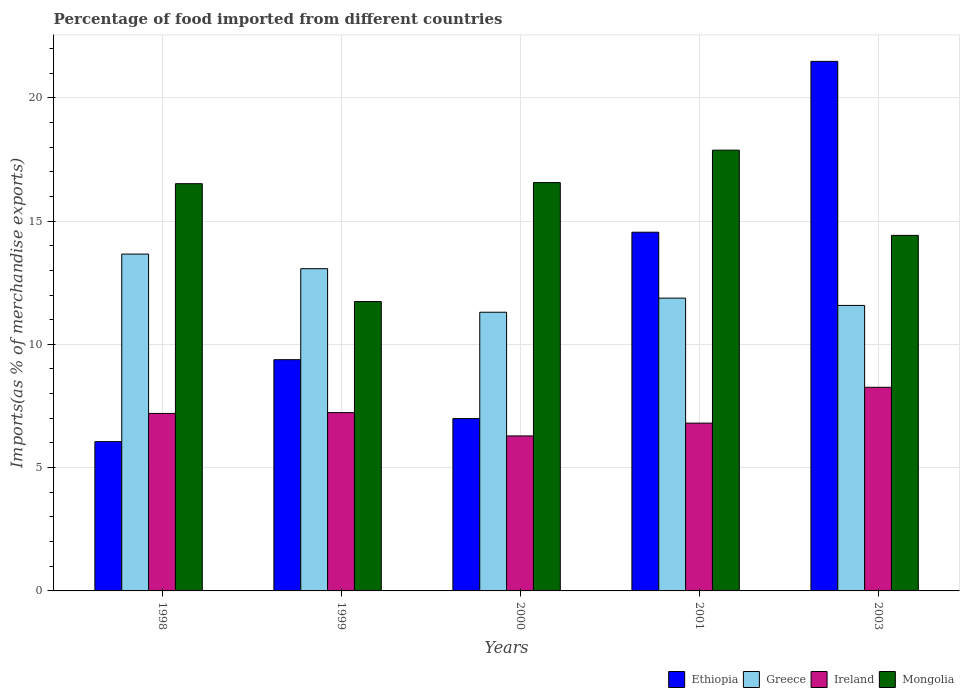Are the number of bars on each tick of the X-axis equal?
Your answer should be very brief. Yes. How many bars are there on the 4th tick from the right?
Offer a very short reply. 4. What is the label of the 2nd group of bars from the left?
Offer a terse response. 1999. In how many cases, is the number of bars for a given year not equal to the number of legend labels?
Your answer should be very brief. 0. What is the percentage of imports to different countries in Ethiopia in 2000?
Keep it short and to the point. 6.99. Across all years, what is the maximum percentage of imports to different countries in Ireland?
Offer a terse response. 8.26. Across all years, what is the minimum percentage of imports to different countries in Greece?
Your answer should be compact. 11.3. In which year was the percentage of imports to different countries in Ireland maximum?
Provide a succinct answer. 2003. In which year was the percentage of imports to different countries in Ireland minimum?
Provide a succinct answer. 2000. What is the total percentage of imports to different countries in Greece in the graph?
Provide a short and direct response. 61.48. What is the difference between the percentage of imports to different countries in Greece in 1999 and that in 2000?
Offer a terse response. 1.77. What is the difference between the percentage of imports to different countries in Greece in 1998 and the percentage of imports to different countries in Mongolia in 2001?
Your answer should be very brief. -4.21. What is the average percentage of imports to different countries in Mongolia per year?
Keep it short and to the point. 15.42. In the year 2003, what is the difference between the percentage of imports to different countries in Ireland and percentage of imports to different countries in Ethiopia?
Keep it short and to the point. -13.22. What is the ratio of the percentage of imports to different countries in Ethiopia in 2000 to that in 2003?
Offer a very short reply. 0.33. Is the difference between the percentage of imports to different countries in Ireland in 1998 and 2000 greater than the difference between the percentage of imports to different countries in Ethiopia in 1998 and 2000?
Your answer should be very brief. Yes. What is the difference between the highest and the second highest percentage of imports to different countries in Mongolia?
Your response must be concise. 1.31. What is the difference between the highest and the lowest percentage of imports to different countries in Mongolia?
Provide a short and direct response. 6.14. In how many years, is the percentage of imports to different countries in Greece greater than the average percentage of imports to different countries in Greece taken over all years?
Offer a terse response. 2. What does the 4th bar from the left in 2003 represents?
Keep it short and to the point. Mongolia. What does the 4th bar from the right in 2003 represents?
Give a very brief answer. Ethiopia. How many bars are there?
Provide a short and direct response. 20. How many years are there in the graph?
Provide a short and direct response. 5. Are the values on the major ticks of Y-axis written in scientific E-notation?
Ensure brevity in your answer.  No. Does the graph contain any zero values?
Give a very brief answer. No. Does the graph contain grids?
Your answer should be very brief. Yes. Where does the legend appear in the graph?
Your response must be concise. Bottom right. How are the legend labels stacked?
Your response must be concise. Horizontal. What is the title of the graph?
Keep it short and to the point. Percentage of food imported from different countries. Does "Portugal" appear as one of the legend labels in the graph?
Keep it short and to the point. No. What is the label or title of the X-axis?
Your answer should be compact. Years. What is the label or title of the Y-axis?
Make the answer very short. Imports(as % of merchandise exports). What is the Imports(as % of merchandise exports) in Ethiopia in 1998?
Offer a very short reply. 6.05. What is the Imports(as % of merchandise exports) in Greece in 1998?
Provide a short and direct response. 13.66. What is the Imports(as % of merchandise exports) of Ireland in 1998?
Provide a short and direct response. 7.2. What is the Imports(as % of merchandise exports) in Mongolia in 1998?
Offer a very short reply. 16.51. What is the Imports(as % of merchandise exports) in Ethiopia in 1999?
Provide a succinct answer. 9.38. What is the Imports(as % of merchandise exports) in Greece in 1999?
Give a very brief answer. 13.07. What is the Imports(as % of merchandise exports) of Ireland in 1999?
Give a very brief answer. 7.23. What is the Imports(as % of merchandise exports) in Mongolia in 1999?
Ensure brevity in your answer.  11.73. What is the Imports(as % of merchandise exports) of Ethiopia in 2000?
Give a very brief answer. 6.99. What is the Imports(as % of merchandise exports) of Greece in 2000?
Offer a very short reply. 11.3. What is the Imports(as % of merchandise exports) of Ireland in 2000?
Offer a terse response. 6.29. What is the Imports(as % of merchandise exports) of Mongolia in 2000?
Make the answer very short. 16.56. What is the Imports(as % of merchandise exports) in Ethiopia in 2001?
Ensure brevity in your answer.  14.55. What is the Imports(as % of merchandise exports) of Greece in 2001?
Offer a terse response. 11.87. What is the Imports(as % of merchandise exports) of Ireland in 2001?
Give a very brief answer. 6.8. What is the Imports(as % of merchandise exports) in Mongolia in 2001?
Your answer should be very brief. 17.87. What is the Imports(as % of merchandise exports) in Ethiopia in 2003?
Give a very brief answer. 21.47. What is the Imports(as % of merchandise exports) in Greece in 2003?
Your answer should be compact. 11.58. What is the Imports(as % of merchandise exports) of Ireland in 2003?
Give a very brief answer. 8.26. What is the Imports(as % of merchandise exports) of Mongolia in 2003?
Your answer should be compact. 14.42. Across all years, what is the maximum Imports(as % of merchandise exports) in Ethiopia?
Your answer should be compact. 21.47. Across all years, what is the maximum Imports(as % of merchandise exports) of Greece?
Offer a very short reply. 13.66. Across all years, what is the maximum Imports(as % of merchandise exports) of Ireland?
Make the answer very short. 8.26. Across all years, what is the maximum Imports(as % of merchandise exports) of Mongolia?
Offer a terse response. 17.87. Across all years, what is the minimum Imports(as % of merchandise exports) of Ethiopia?
Your response must be concise. 6.05. Across all years, what is the minimum Imports(as % of merchandise exports) in Greece?
Your answer should be compact. 11.3. Across all years, what is the minimum Imports(as % of merchandise exports) in Ireland?
Provide a short and direct response. 6.29. Across all years, what is the minimum Imports(as % of merchandise exports) in Mongolia?
Make the answer very short. 11.73. What is the total Imports(as % of merchandise exports) of Ethiopia in the graph?
Provide a short and direct response. 58.44. What is the total Imports(as % of merchandise exports) of Greece in the graph?
Your answer should be very brief. 61.48. What is the total Imports(as % of merchandise exports) of Ireland in the graph?
Offer a terse response. 35.78. What is the total Imports(as % of merchandise exports) in Mongolia in the graph?
Give a very brief answer. 77.1. What is the difference between the Imports(as % of merchandise exports) of Ethiopia in 1998 and that in 1999?
Make the answer very short. -3.32. What is the difference between the Imports(as % of merchandise exports) of Greece in 1998 and that in 1999?
Offer a terse response. 0.59. What is the difference between the Imports(as % of merchandise exports) of Ireland in 1998 and that in 1999?
Keep it short and to the point. -0.03. What is the difference between the Imports(as % of merchandise exports) in Mongolia in 1998 and that in 1999?
Your response must be concise. 4.78. What is the difference between the Imports(as % of merchandise exports) of Ethiopia in 1998 and that in 2000?
Keep it short and to the point. -0.94. What is the difference between the Imports(as % of merchandise exports) of Greece in 1998 and that in 2000?
Your answer should be compact. 2.36. What is the difference between the Imports(as % of merchandise exports) in Ireland in 1998 and that in 2000?
Ensure brevity in your answer.  0.91. What is the difference between the Imports(as % of merchandise exports) of Mongolia in 1998 and that in 2000?
Ensure brevity in your answer.  -0.05. What is the difference between the Imports(as % of merchandise exports) in Ethiopia in 1998 and that in 2001?
Give a very brief answer. -8.49. What is the difference between the Imports(as % of merchandise exports) in Greece in 1998 and that in 2001?
Make the answer very short. 1.79. What is the difference between the Imports(as % of merchandise exports) in Ireland in 1998 and that in 2001?
Provide a succinct answer. 0.39. What is the difference between the Imports(as % of merchandise exports) of Mongolia in 1998 and that in 2001?
Offer a very short reply. -1.36. What is the difference between the Imports(as % of merchandise exports) in Ethiopia in 1998 and that in 2003?
Offer a very short reply. -15.42. What is the difference between the Imports(as % of merchandise exports) in Greece in 1998 and that in 2003?
Your answer should be compact. 2.08. What is the difference between the Imports(as % of merchandise exports) of Ireland in 1998 and that in 2003?
Provide a succinct answer. -1.06. What is the difference between the Imports(as % of merchandise exports) of Mongolia in 1998 and that in 2003?
Your response must be concise. 2.1. What is the difference between the Imports(as % of merchandise exports) of Ethiopia in 1999 and that in 2000?
Provide a succinct answer. 2.39. What is the difference between the Imports(as % of merchandise exports) in Greece in 1999 and that in 2000?
Provide a succinct answer. 1.77. What is the difference between the Imports(as % of merchandise exports) in Ireland in 1999 and that in 2000?
Your answer should be very brief. 0.95. What is the difference between the Imports(as % of merchandise exports) in Mongolia in 1999 and that in 2000?
Keep it short and to the point. -4.82. What is the difference between the Imports(as % of merchandise exports) of Ethiopia in 1999 and that in 2001?
Keep it short and to the point. -5.17. What is the difference between the Imports(as % of merchandise exports) in Greece in 1999 and that in 2001?
Make the answer very short. 1.19. What is the difference between the Imports(as % of merchandise exports) of Ireland in 1999 and that in 2001?
Your response must be concise. 0.43. What is the difference between the Imports(as % of merchandise exports) of Mongolia in 1999 and that in 2001?
Provide a succinct answer. -6.14. What is the difference between the Imports(as % of merchandise exports) of Ethiopia in 1999 and that in 2003?
Provide a succinct answer. -12.1. What is the difference between the Imports(as % of merchandise exports) of Greece in 1999 and that in 2003?
Your response must be concise. 1.49. What is the difference between the Imports(as % of merchandise exports) in Ireland in 1999 and that in 2003?
Offer a terse response. -1.03. What is the difference between the Imports(as % of merchandise exports) of Mongolia in 1999 and that in 2003?
Make the answer very short. -2.68. What is the difference between the Imports(as % of merchandise exports) of Ethiopia in 2000 and that in 2001?
Provide a succinct answer. -7.56. What is the difference between the Imports(as % of merchandise exports) in Greece in 2000 and that in 2001?
Ensure brevity in your answer.  -0.57. What is the difference between the Imports(as % of merchandise exports) of Ireland in 2000 and that in 2001?
Provide a short and direct response. -0.52. What is the difference between the Imports(as % of merchandise exports) in Mongolia in 2000 and that in 2001?
Your answer should be compact. -1.31. What is the difference between the Imports(as % of merchandise exports) in Ethiopia in 2000 and that in 2003?
Provide a succinct answer. -14.49. What is the difference between the Imports(as % of merchandise exports) of Greece in 2000 and that in 2003?
Your answer should be compact. -0.28. What is the difference between the Imports(as % of merchandise exports) in Ireland in 2000 and that in 2003?
Provide a succinct answer. -1.97. What is the difference between the Imports(as % of merchandise exports) in Mongolia in 2000 and that in 2003?
Provide a succinct answer. 2.14. What is the difference between the Imports(as % of merchandise exports) in Ethiopia in 2001 and that in 2003?
Your answer should be very brief. -6.93. What is the difference between the Imports(as % of merchandise exports) of Greece in 2001 and that in 2003?
Your answer should be compact. 0.3. What is the difference between the Imports(as % of merchandise exports) of Ireland in 2001 and that in 2003?
Offer a terse response. -1.45. What is the difference between the Imports(as % of merchandise exports) in Mongolia in 2001 and that in 2003?
Provide a short and direct response. 3.46. What is the difference between the Imports(as % of merchandise exports) in Ethiopia in 1998 and the Imports(as % of merchandise exports) in Greece in 1999?
Provide a succinct answer. -7.01. What is the difference between the Imports(as % of merchandise exports) in Ethiopia in 1998 and the Imports(as % of merchandise exports) in Ireland in 1999?
Your answer should be very brief. -1.18. What is the difference between the Imports(as % of merchandise exports) in Ethiopia in 1998 and the Imports(as % of merchandise exports) in Mongolia in 1999?
Your answer should be very brief. -5.68. What is the difference between the Imports(as % of merchandise exports) in Greece in 1998 and the Imports(as % of merchandise exports) in Ireland in 1999?
Give a very brief answer. 6.43. What is the difference between the Imports(as % of merchandise exports) of Greece in 1998 and the Imports(as % of merchandise exports) of Mongolia in 1999?
Offer a terse response. 1.93. What is the difference between the Imports(as % of merchandise exports) of Ireland in 1998 and the Imports(as % of merchandise exports) of Mongolia in 1999?
Offer a very short reply. -4.54. What is the difference between the Imports(as % of merchandise exports) in Ethiopia in 1998 and the Imports(as % of merchandise exports) in Greece in 2000?
Provide a succinct answer. -5.25. What is the difference between the Imports(as % of merchandise exports) of Ethiopia in 1998 and the Imports(as % of merchandise exports) of Ireland in 2000?
Your answer should be compact. -0.23. What is the difference between the Imports(as % of merchandise exports) in Ethiopia in 1998 and the Imports(as % of merchandise exports) in Mongolia in 2000?
Give a very brief answer. -10.5. What is the difference between the Imports(as % of merchandise exports) of Greece in 1998 and the Imports(as % of merchandise exports) of Ireland in 2000?
Your answer should be very brief. 7.37. What is the difference between the Imports(as % of merchandise exports) in Greece in 1998 and the Imports(as % of merchandise exports) in Mongolia in 2000?
Give a very brief answer. -2.9. What is the difference between the Imports(as % of merchandise exports) in Ireland in 1998 and the Imports(as % of merchandise exports) in Mongolia in 2000?
Make the answer very short. -9.36. What is the difference between the Imports(as % of merchandise exports) of Ethiopia in 1998 and the Imports(as % of merchandise exports) of Greece in 2001?
Your response must be concise. -5.82. What is the difference between the Imports(as % of merchandise exports) in Ethiopia in 1998 and the Imports(as % of merchandise exports) in Ireland in 2001?
Your answer should be compact. -0.75. What is the difference between the Imports(as % of merchandise exports) of Ethiopia in 1998 and the Imports(as % of merchandise exports) of Mongolia in 2001?
Your answer should be very brief. -11.82. What is the difference between the Imports(as % of merchandise exports) in Greece in 1998 and the Imports(as % of merchandise exports) in Ireland in 2001?
Provide a succinct answer. 6.85. What is the difference between the Imports(as % of merchandise exports) of Greece in 1998 and the Imports(as % of merchandise exports) of Mongolia in 2001?
Give a very brief answer. -4.21. What is the difference between the Imports(as % of merchandise exports) in Ireland in 1998 and the Imports(as % of merchandise exports) in Mongolia in 2001?
Provide a succinct answer. -10.68. What is the difference between the Imports(as % of merchandise exports) of Ethiopia in 1998 and the Imports(as % of merchandise exports) of Greece in 2003?
Keep it short and to the point. -5.52. What is the difference between the Imports(as % of merchandise exports) of Ethiopia in 1998 and the Imports(as % of merchandise exports) of Ireland in 2003?
Your answer should be very brief. -2.2. What is the difference between the Imports(as % of merchandise exports) of Ethiopia in 1998 and the Imports(as % of merchandise exports) of Mongolia in 2003?
Give a very brief answer. -8.36. What is the difference between the Imports(as % of merchandise exports) of Greece in 1998 and the Imports(as % of merchandise exports) of Ireland in 2003?
Offer a terse response. 5.4. What is the difference between the Imports(as % of merchandise exports) of Greece in 1998 and the Imports(as % of merchandise exports) of Mongolia in 2003?
Ensure brevity in your answer.  -0.76. What is the difference between the Imports(as % of merchandise exports) of Ireland in 1998 and the Imports(as % of merchandise exports) of Mongolia in 2003?
Your response must be concise. -7.22. What is the difference between the Imports(as % of merchandise exports) in Ethiopia in 1999 and the Imports(as % of merchandise exports) in Greece in 2000?
Offer a terse response. -1.93. What is the difference between the Imports(as % of merchandise exports) in Ethiopia in 1999 and the Imports(as % of merchandise exports) in Ireland in 2000?
Your answer should be compact. 3.09. What is the difference between the Imports(as % of merchandise exports) of Ethiopia in 1999 and the Imports(as % of merchandise exports) of Mongolia in 2000?
Make the answer very short. -7.18. What is the difference between the Imports(as % of merchandise exports) in Greece in 1999 and the Imports(as % of merchandise exports) in Ireland in 2000?
Your response must be concise. 6.78. What is the difference between the Imports(as % of merchandise exports) of Greece in 1999 and the Imports(as % of merchandise exports) of Mongolia in 2000?
Make the answer very short. -3.49. What is the difference between the Imports(as % of merchandise exports) of Ireland in 1999 and the Imports(as % of merchandise exports) of Mongolia in 2000?
Make the answer very short. -9.33. What is the difference between the Imports(as % of merchandise exports) of Ethiopia in 1999 and the Imports(as % of merchandise exports) of Greece in 2001?
Ensure brevity in your answer.  -2.5. What is the difference between the Imports(as % of merchandise exports) in Ethiopia in 1999 and the Imports(as % of merchandise exports) in Ireland in 2001?
Provide a succinct answer. 2.57. What is the difference between the Imports(as % of merchandise exports) in Ethiopia in 1999 and the Imports(as % of merchandise exports) in Mongolia in 2001?
Your response must be concise. -8.5. What is the difference between the Imports(as % of merchandise exports) of Greece in 1999 and the Imports(as % of merchandise exports) of Ireland in 2001?
Keep it short and to the point. 6.26. What is the difference between the Imports(as % of merchandise exports) in Greece in 1999 and the Imports(as % of merchandise exports) in Mongolia in 2001?
Keep it short and to the point. -4.81. What is the difference between the Imports(as % of merchandise exports) of Ireland in 1999 and the Imports(as % of merchandise exports) of Mongolia in 2001?
Your answer should be compact. -10.64. What is the difference between the Imports(as % of merchandise exports) of Ethiopia in 1999 and the Imports(as % of merchandise exports) of Greece in 2003?
Keep it short and to the point. -2.2. What is the difference between the Imports(as % of merchandise exports) of Ethiopia in 1999 and the Imports(as % of merchandise exports) of Ireland in 2003?
Your response must be concise. 1.12. What is the difference between the Imports(as % of merchandise exports) in Ethiopia in 1999 and the Imports(as % of merchandise exports) in Mongolia in 2003?
Your answer should be very brief. -5.04. What is the difference between the Imports(as % of merchandise exports) of Greece in 1999 and the Imports(as % of merchandise exports) of Ireland in 2003?
Make the answer very short. 4.81. What is the difference between the Imports(as % of merchandise exports) in Greece in 1999 and the Imports(as % of merchandise exports) in Mongolia in 2003?
Your answer should be compact. -1.35. What is the difference between the Imports(as % of merchandise exports) of Ireland in 1999 and the Imports(as % of merchandise exports) of Mongolia in 2003?
Make the answer very short. -7.19. What is the difference between the Imports(as % of merchandise exports) of Ethiopia in 2000 and the Imports(as % of merchandise exports) of Greece in 2001?
Provide a short and direct response. -4.88. What is the difference between the Imports(as % of merchandise exports) in Ethiopia in 2000 and the Imports(as % of merchandise exports) in Ireland in 2001?
Your answer should be compact. 0.18. What is the difference between the Imports(as % of merchandise exports) of Ethiopia in 2000 and the Imports(as % of merchandise exports) of Mongolia in 2001?
Make the answer very short. -10.88. What is the difference between the Imports(as % of merchandise exports) in Greece in 2000 and the Imports(as % of merchandise exports) in Ireland in 2001?
Your answer should be compact. 4.5. What is the difference between the Imports(as % of merchandise exports) in Greece in 2000 and the Imports(as % of merchandise exports) in Mongolia in 2001?
Make the answer very short. -6.57. What is the difference between the Imports(as % of merchandise exports) in Ireland in 2000 and the Imports(as % of merchandise exports) in Mongolia in 2001?
Provide a succinct answer. -11.59. What is the difference between the Imports(as % of merchandise exports) in Ethiopia in 2000 and the Imports(as % of merchandise exports) in Greece in 2003?
Make the answer very short. -4.59. What is the difference between the Imports(as % of merchandise exports) in Ethiopia in 2000 and the Imports(as % of merchandise exports) in Ireland in 2003?
Ensure brevity in your answer.  -1.27. What is the difference between the Imports(as % of merchandise exports) of Ethiopia in 2000 and the Imports(as % of merchandise exports) of Mongolia in 2003?
Make the answer very short. -7.43. What is the difference between the Imports(as % of merchandise exports) in Greece in 2000 and the Imports(as % of merchandise exports) in Ireland in 2003?
Offer a terse response. 3.04. What is the difference between the Imports(as % of merchandise exports) of Greece in 2000 and the Imports(as % of merchandise exports) of Mongolia in 2003?
Your response must be concise. -3.12. What is the difference between the Imports(as % of merchandise exports) of Ireland in 2000 and the Imports(as % of merchandise exports) of Mongolia in 2003?
Your answer should be very brief. -8.13. What is the difference between the Imports(as % of merchandise exports) of Ethiopia in 2001 and the Imports(as % of merchandise exports) of Greece in 2003?
Give a very brief answer. 2.97. What is the difference between the Imports(as % of merchandise exports) of Ethiopia in 2001 and the Imports(as % of merchandise exports) of Ireland in 2003?
Give a very brief answer. 6.29. What is the difference between the Imports(as % of merchandise exports) of Ethiopia in 2001 and the Imports(as % of merchandise exports) of Mongolia in 2003?
Your answer should be compact. 0.13. What is the difference between the Imports(as % of merchandise exports) of Greece in 2001 and the Imports(as % of merchandise exports) of Ireland in 2003?
Make the answer very short. 3.61. What is the difference between the Imports(as % of merchandise exports) of Greece in 2001 and the Imports(as % of merchandise exports) of Mongolia in 2003?
Your answer should be compact. -2.54. What is the difference between the Imports(as % of merchandise exports) in Ireland in 2001 and the Imports(as % of merchandise exports) in Mongolia in 2003?
Ensure brevity in your answer.  -7.61. What is the average Imports(as % of merchandise exports) in Ethiopia per year?
Offer a very short reply. 11.69. What is the average Imports(as % of merchandise exports) in Greece per year?
Offer a very short reply. 12.3. What is the average Imports(as % of merchandise exports) of Ireland per year?
Make the answer very short. 7.16. What is the average Imports(as % of merchandise exports) of Mongolia per year?
Ensure brevity in your answer.  15.42. In the year 1998, what is the difference between the Imports(as % of merchandise exports) of Ethiopia and Imports(as % of merchandise exports) of Greece?
Provide a short and direct response. -7.61. In the year 1998, what is the difference between the Imports(as % of merchandise exports) in Ethiopia and Imports(as % of merchandise exports) in Ireland?
Ensure brevity in your answer.  -1.14. In the year 1998, what is the difference between the Imports(as % of merchandise exports) in Ethiopia and Imports(as % of merchandise exports) in Mongolia?
Your response must be concise. -10.46. In the year 1998, what is the difference between the Imports(as % of merchandise exports) of Greece and Imports(as % of merchandise exports) of Ireland?
Ensure brevity in your answer.  6.46. In the year 1998, what is the difference between the Imports(as % of merchandise exports) in Greece and Imports(as % of merchandise exports) in Mongolia?
Your answer should be very brief. -2.85. In the year 1998, what is the difference between the Imports(as % of merchandise exports) in Ireland and Imports(as % of merchandise exports) in Mongolia?
Give a very brief answer. -9.32. In the year 1999, what is the difference between the Imports(as % of merchandise exports) in Ethiopia and Imports(as % of merchandise exports) in Greece?
Provide a short and direct response. -3.69. In the year 1999, what is the difference between the Imports(as % of merchandise exports) in Ethiopia and Imports(as % of merchandise exports) in Ireland?
Make the answer very short. 2.15. In the year 1999, what is the difference between the Imports(as % of merchandise exports) in Ethiopia and Imports(as % of merchandise exports) in Mongolia?
Your answer should be compact. -2.36. In the year 1999, what is the difference between the Imports(as % of merchandise exports) in Greece and Imports(as % of merchandise exports) in Ireland?
Offer a very short reply. 5.84. In the year 1999, what is the difference between the Imports(as % of merchandise exports) in Greece and Imports(as % of merchandise exports) in Mongolia?
Make the answer very short. 1.33. In the year 1999, what is the difference between the Imports(as % of merchandise exports) of Ireland and Imports(as % of merchandise exports) of Mongolia?
Your answer should be compact. -4.5. In the year 2000, what is the difference between the Imports(as % of merchandise exports) of Ethiopia and Imports(as % of merchandise exports) of Greece?
Keep it short and to the point. -4.31. In the year 2000, what is the difference between the Imports(as % of merchandise exports) in Ethiopia and Imports(as % of merchandise exports) in Ireland?
Provide a succinct answer. 0.7. In the year 2000, what is the difference between the Imports(as % of merchandise exports) in Ethiopia and Imports(as % of merchandise exports) in Mongolia?
Make the answer very short. -9.57. In the year 2000, what is the difference between the Imports(as % of merchandise exports) in Greece and Imports(as % of merchandise exports) in Ireland?
Provide a short and direct response. 5.02. In the year 2000, what is the difference between the Imports(as % of merchandise exports) of Greece and Imports(as % of merchandise exports) of Mongolia?
Provide a succinct answer. -5.26. In the year 2000, what is the difference between the Imports(as % of merchandise exports) of Ireland and Imports(as % of merchandise exports) of Mongolia?
Provide a succinct answer. -10.27. In the year 2001, what is the difference between the Imports(as % of merchandise exports) in Ethiopia and Imports(as % of merchandise exports) in Greece?
Keep it short and to the point. 2.67. In the year 2001, what is the difference between the Imports(as % of merchandise exports) of Ethiopia and Imports(as % of merchandise exports) of Ireland?
Your answer should be compact. 7.74. In the year 2001, what is the difference between the Imports(as % of merchandise exports) of Ethiopia and Imports(as % of merchandise exports) of Mongolia?
Provide a short and direct response. -3.33. In the year 2001, what is the difference between the Imports(as % of merchandise exports) of Greece and Imports(as % of merchandise exports) of Ireland?
Keep it short and to the point. 5.07. In the year 2001, what is the difference between the Imports(as % of merchandise exports) of Greece and Imports(as % of merchandise exports) of Mongolia?
Your answer should be very brief. -6. In the year 2001, what is the difference between the Imports(as % of merchandise exports) of Ireland and Imports(as % of merchandise exports) of Mongolia?
Provide a succinct answer. -11.07. In the year 2003, what is the difference between the Imports(as % of merchandise exports) in Ethiopia and Imports(as % of merchandise exports) in Greece?
Ensure brevity in your answer.  9.9. In the year 2003, what is the difference between the Imports(as % of merchandise exports) in Ethiopia and Imports(as % of merchandise exports) in Ireland?
Offer a very short reply. 13.22. In the year 2003, what is the difference between the Imports(as % of merchandise exports) in Ethiopia and Imports(as % of merchandise exports) in Mongolia?
Ensure brevity in your answer.  7.06. In the year 2003, what is the difference between the Imports(as % of merchandise exports) of Greece and Imports(as % of merchandise exports) of Ireland?
Give a very brief answer. 3.32. In the year 2003, what is the difference between the Imports(as % of merchandise exports) of Greece and Imports(as % of merchandise exports) of Mongolia?
Make the answer very short. -2.84. In the year 2003, what is the difference between the Imports(as % of merchandise exports) in Ireland and Imports(as % of merchandise exports) in Mongolia?
Provide a succinct answer. -6.16. What is the ratio of the Imports(as % of merchandise exports) of Ethiopia in 1998 to that in 1999?
Make the answer very short. 0.65. What is the ratio of the Imports(as % of merchandise exports) of Greece in 1998 to that in 1999?
Provide a short and direct response. 1.05. What is the ratio of the Imports(as % of merchandise exports) of Ireland in 1998 to that in 1999?
Make the answer very short. 1. What is the ratio of the Imports(as % of merchandise exports) in Mongolia in 1998 to that in 1999?
Your answer should be compact. 1.41. What is the ratio of the Imports(as % of merchandise exports) in Ethiopia in 1998 to that in 2000?
Keep it short and to the point. 0.87. What is the ratio of the Imports(as % of merchandise exports) of Greece in 1998 to that in 2000?
Ensure brevity in your answer.  1.21. What is the ratio of the Imports(as % of merchandise exports) in Ireland in 1998 to that in 2000?
Your answer should be very brief. 1.15. What is the ratio of the Imports(as % of merchandise exports) in Mongolia in 1998 to that in 2000?
Provide a succinct answer. 1. What is the ratio of the Imports(as % of merchandise exports) of Ethiopia in 1998 to that in 2001?
Your response must be concise. 0.42. What is the ratio of the Imports(as % of merchandise exports) in Greece in 1998 to that in 2001?
Your answer should be very brief. 1.15. What is the ratio of the Imports(as % of merchandise exports) of Ireland in 1998 to that in 2001?
Provide a succinct answer. 1.06. What is the ratio of the Imports(as % of merchandise exports) of Mongolia in 1998 to that in 2001?
Keep it short and to the point. 0.92. What is the ratio of the Imports(as % of merchandise exports) in Ethiopia in 1998 to that in 2003?
Your response must be concise. 0.28. What is the ratio of the Imports(as % of merchandise exports) in Greece in 1998 to that in 2003?
Give a very brief answer. 1.18. What is the ratio of the Imports(as % of merchandise exports) of Ireland in 1998 to that in 2003?
Keep it short and to the point. 0.87. What is the ratio of the Imports(as % of merchandise exports) in Mongolia in 1998 to that in 2003?
Keep it short and to the point. 1.15. What is the ratio of the Imports(as % of merchandise exports) of Ethiopia in 1999 to that in 2000?
Offer a terse response. 1.34. What is the ratio of the Imports(as % of merchandise exports) of Greece in 1999 to that in 2000?
Provide a short and direct response. 1.16. What is the ratio of the Imports(as % of merchandise exports) in Ireland in 1999 to that in 2000?
Provide a succinct answer. 1.15. What is the ratio of the Imports(as % of merchandise exports) in Mongolia in 1999 to that in 2000?
Offer a very short reply. 0.71. What is the ratio of the Imports(as % of merchandise exports) in Ethiopia in 1999 to that in 2001?
Ensure brevity in your answer.  0.64. What is the ratio of the Imports(as % of merchandise exports) of Greece in 1999 to that in 2001?
Keep it short and to the point. 1.1. What is the ratio of the Imports(as % of merchandise exports) of Mongolia in 1999 to that in 2001?
Your response must be concise. 0.66. What is the ratio of the Imports(as % of merchandise exports) in Ethiopia in 1999 to that in 2003?
Make the answer very short. 0.44. What is the ratio of the Imports(as % of merchandise exports) in Greece in 1999 to that in 2003?
Your response must be concise. 1.13. What is the ratio of the Imports(as % of merchandise exports) of Ireland in 1999 to that in 2003?
Offer a terse response. 0.88. What is the ratio of the Imports(as % of merchandise exports) of Mongolia in 1999 to that in 2003?
Offer a terse response. 0.81. What is the ratio of the Imports(as % of merchandise exports) in Ethiopia in 2000 to that in 2001?
Provide a succinct answer. 0.48. What is the ratio of the Imports(as % of merchandise exports) in Greece in 2000 to that in 2001?
Your response must be concise. 0.95. What is the ratio of the Imports(as % of merchandise exports) in Ireland in 2000 to that in 2001?
Keep it short and to the point. 0.92. What is the ratio of the Imports(as % of merchandise exports) of Mongolia in 2000 to that in 2001?
Your answer should be compact. 0.93. What is the ratio of the Imports(as % of merchandise exports) of Ethiopia in 2000 to that in 2003?
Provide a short and direct response. 0.33. What is the ratio of the Imports(as % of merchandise exports) of Greece in 2000 to that in 2003?
Provide a succinct answer. 0.98. What is the ratio of the Imports(as % of merchandise exports) of Ireland in 2000 to that in 2003?
Keep it short and to the point. 0.76. What is the ratio of the Imports(as % of merchandise exports) of Mongolia in 2000 to that in 2003?
Offer a very short reply. 1.15. What is the ratio of the Imports(as % of merchandise exports) in Ethiopia in 2001 to that in 2003?
Provide a short and direct response. 0.68. What is the ratio of the Imports(as % of merchandise exports) of Greece in 2001 to that in 2003?
Offer a terse response. 1.03. What is the ratio of the Imports(as % of merchandise exports) of Ireland in 2001 to that in 2003?
Give a very brief answer. 0.82. What is the ratio of the Imports(as % of merchandise exports) of Mongolia in 2001 to that in 2003?
Your response must be concise. 1.24. What is the difference between the highest and the second highest Imports(as % of merchandise exports) in Ethiopia?
Provide a succinct answer. 6.93. What is the difference between the highest and the second highest Imports(as % of merchandise exports) of Greece?
Keep it short and to the point. 0.59. What is the difference between the highest and the second highest Imports(as % of merchandise exports) in Ireland?
Your answer should be compact. 1.03. What is the difference between the highest and the second highest Imports(as % of merchandise exports) in Mongolia?
Provide a succinct answer. 1.31. What is the difference between the highest and the lowest Imports(as % of merchandise exports) in Ethiopia?
Make the answer very short. 15.42. What is the difference between the highest and the lowest Imports(as % of merchandise exports) in Greece?
Keep it short and to the point. 2.36. What is the difference between the highest and the lowest Imports(as % of merchandise exports) in Ireland?
Provide a short and direct response. 1.97. What is the difference between the highest and the lowest Imports(as % of merchandise exports) of Mongolia?
Provide a succinct answer. 6.14. 